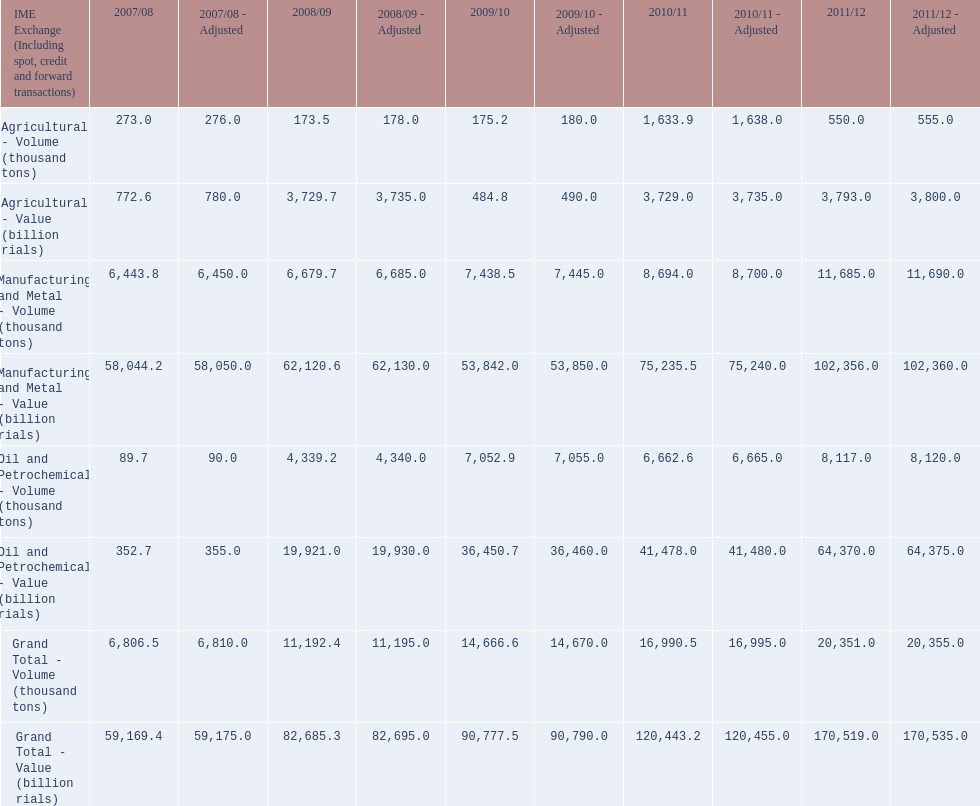How many consecutive year did the grand total value grow in iran? 4. 